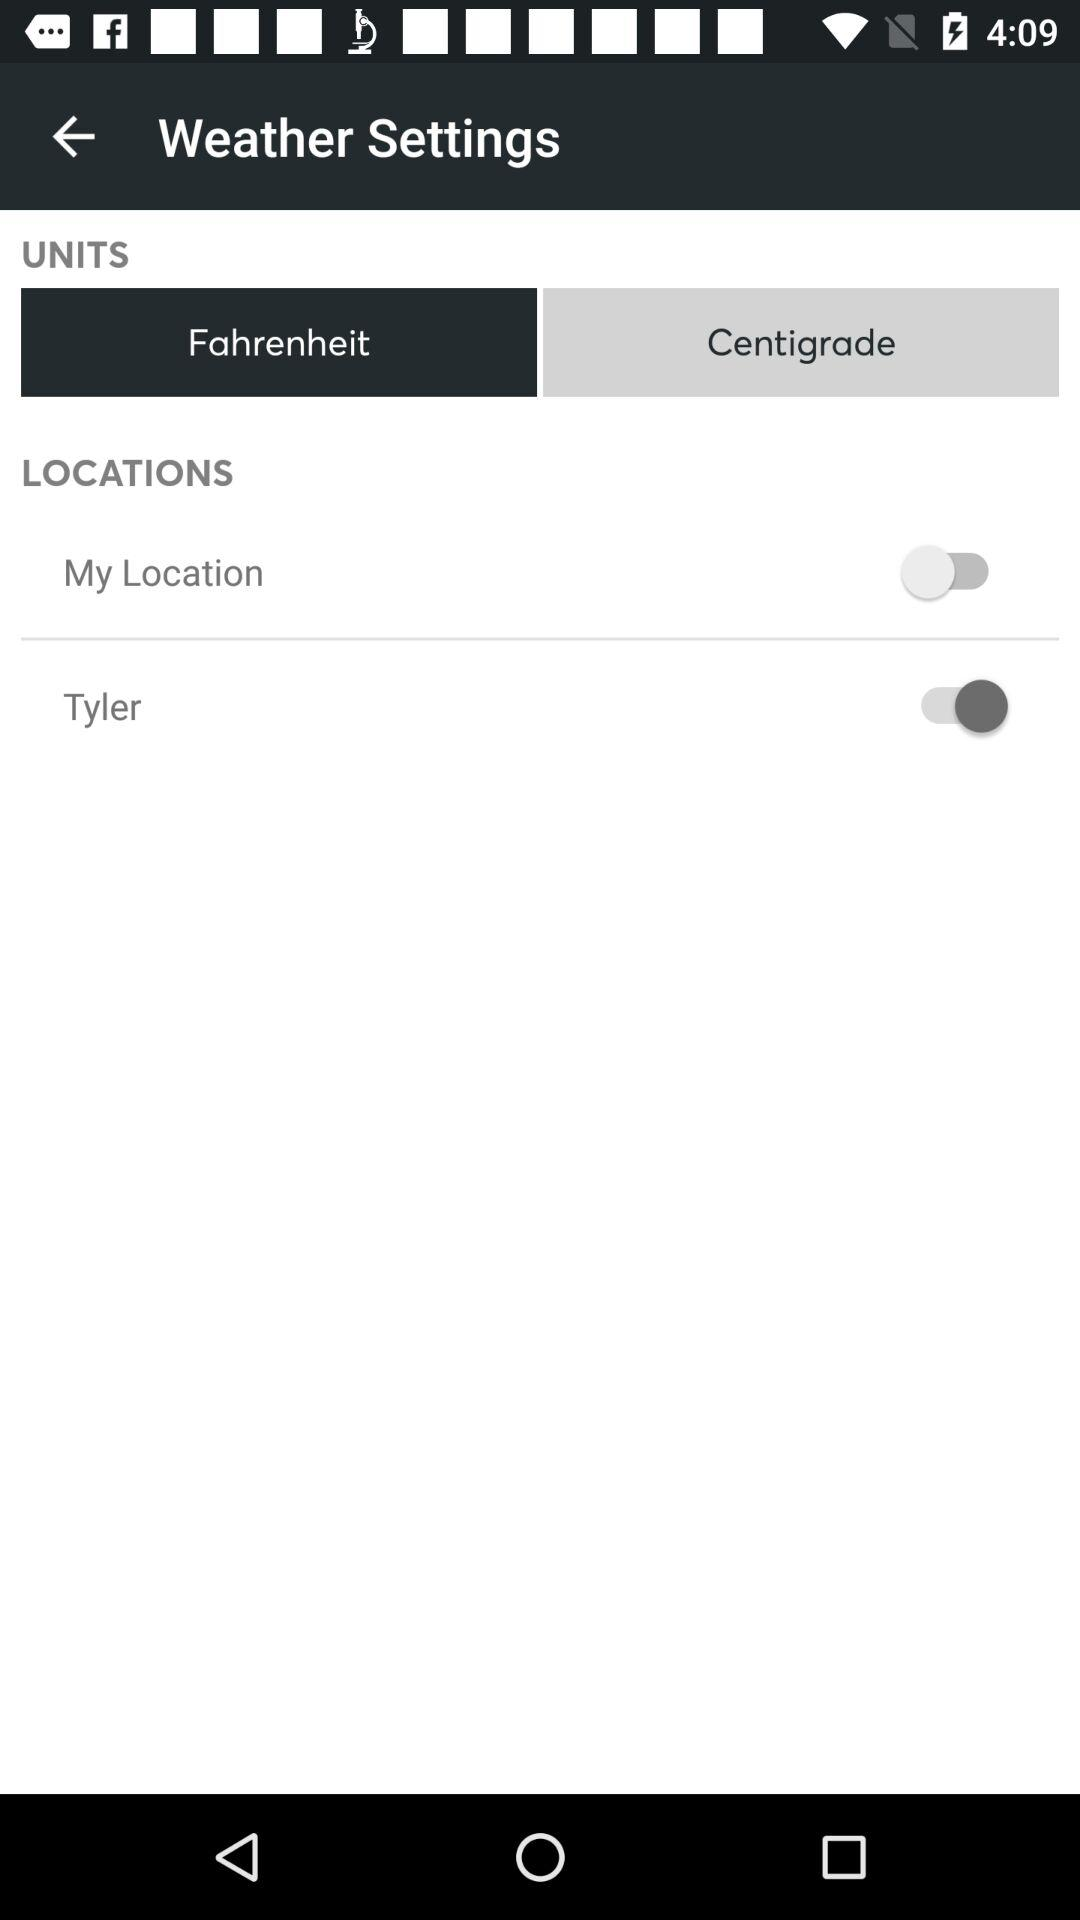For what option is the status on? The status is on for "Tyler". 